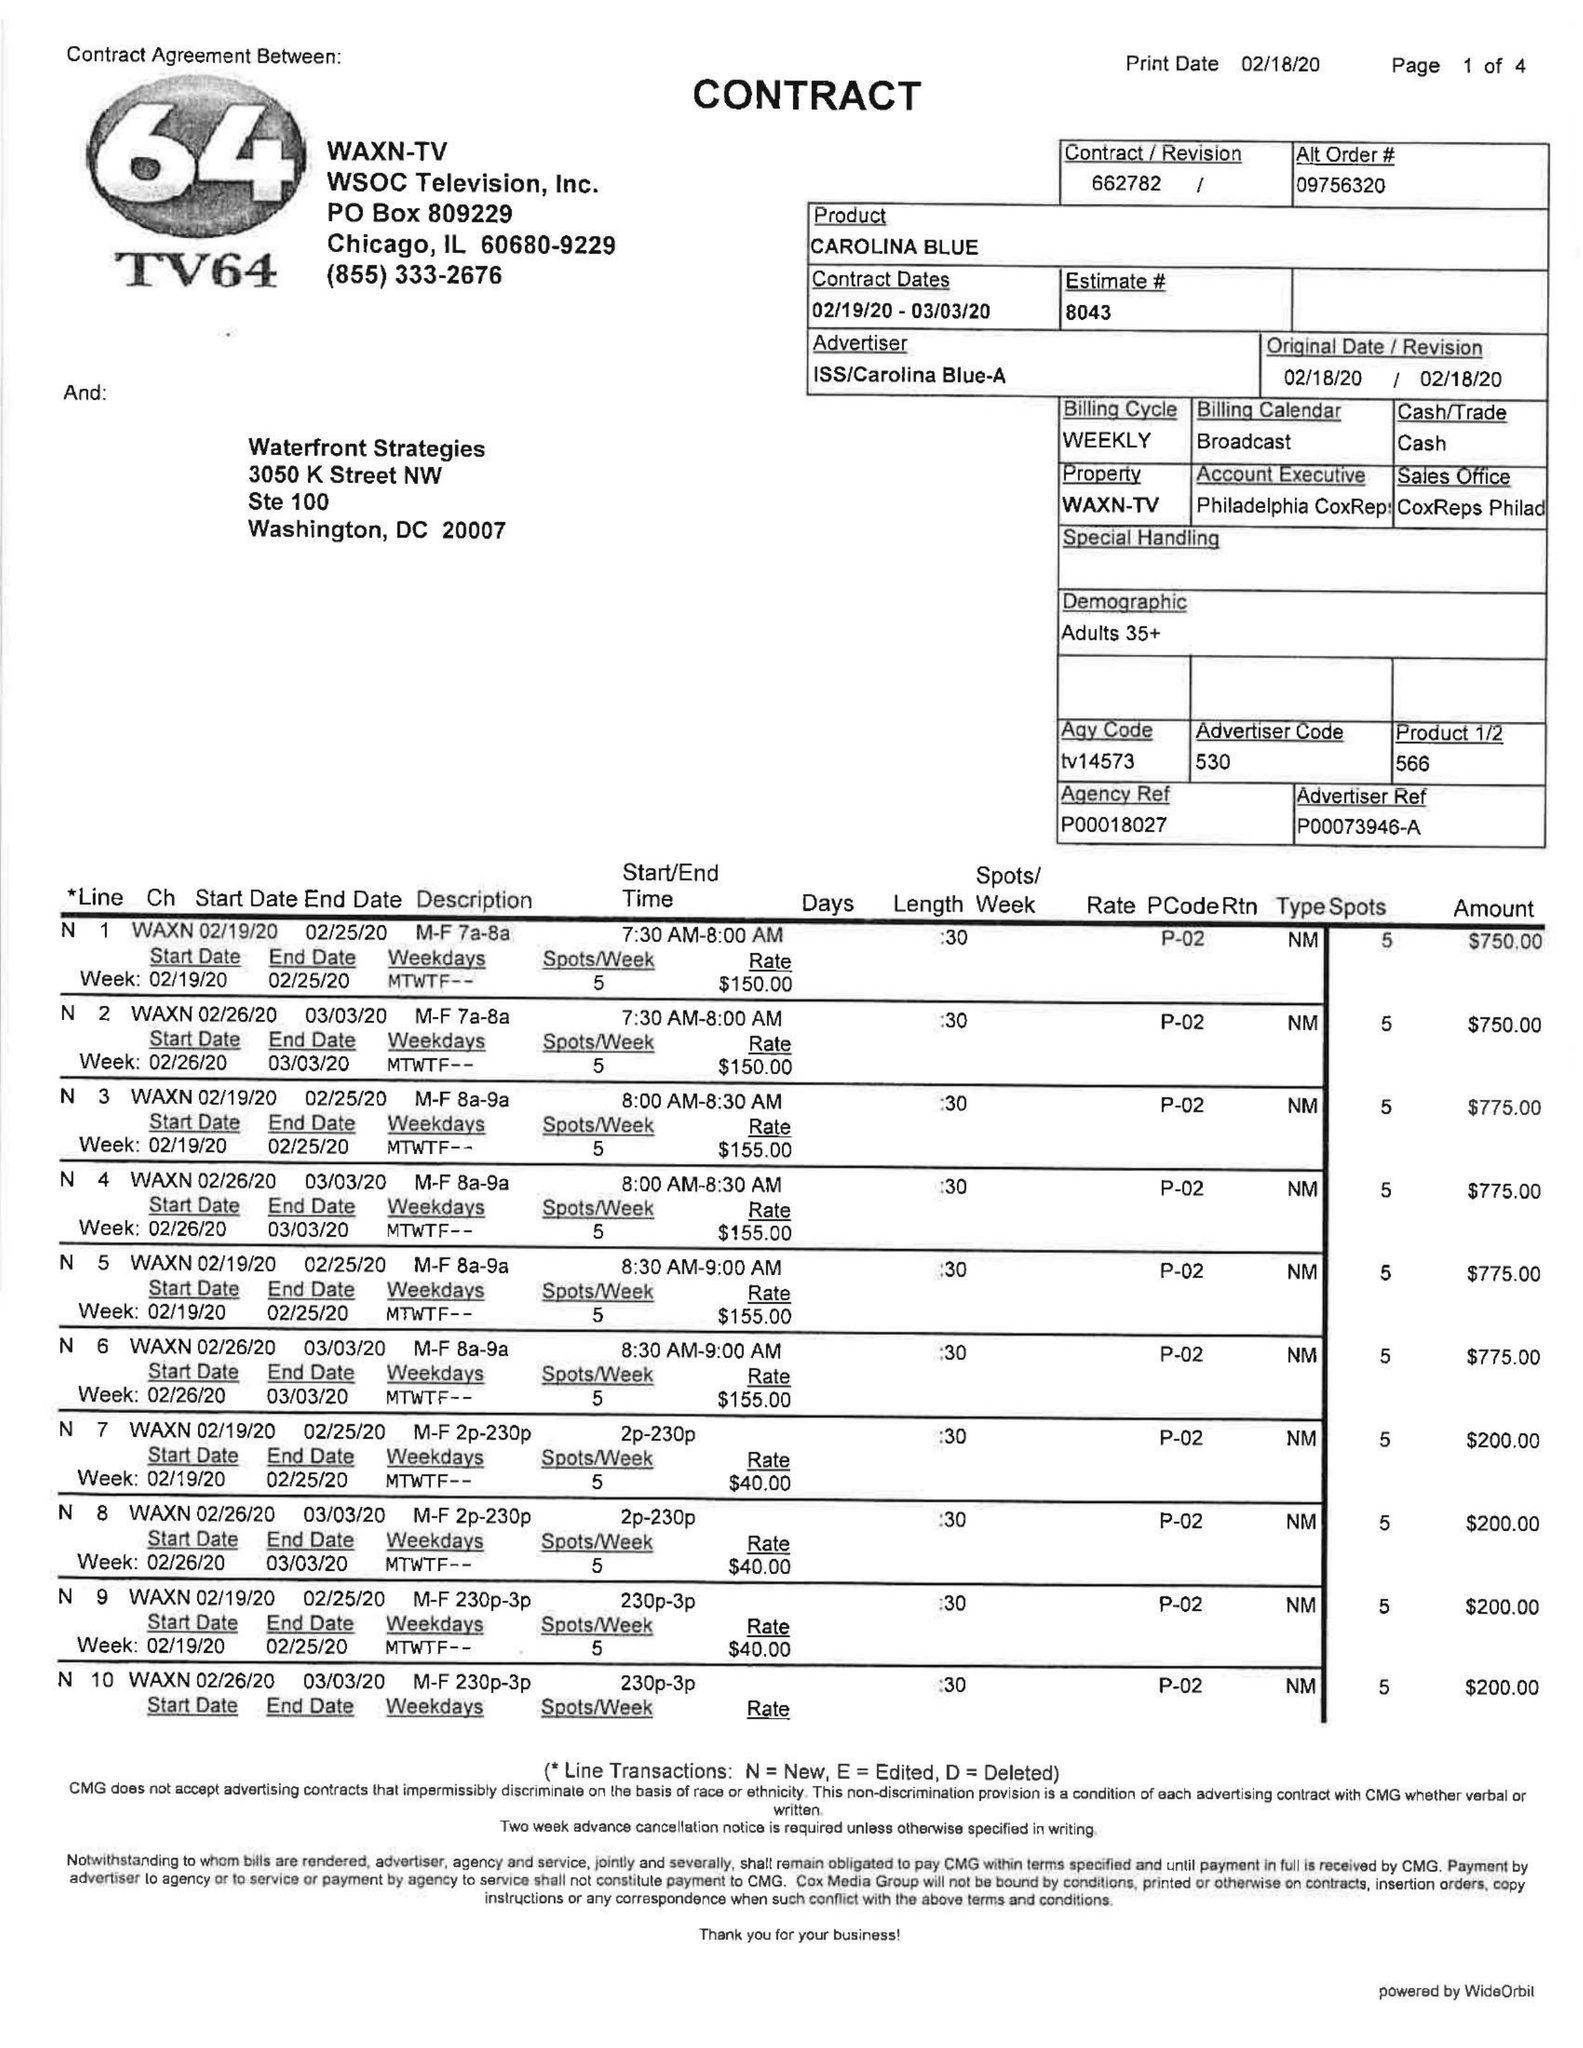What is the value for the gross_amount?
Answer the question using a single word or phrase. 24890.00 